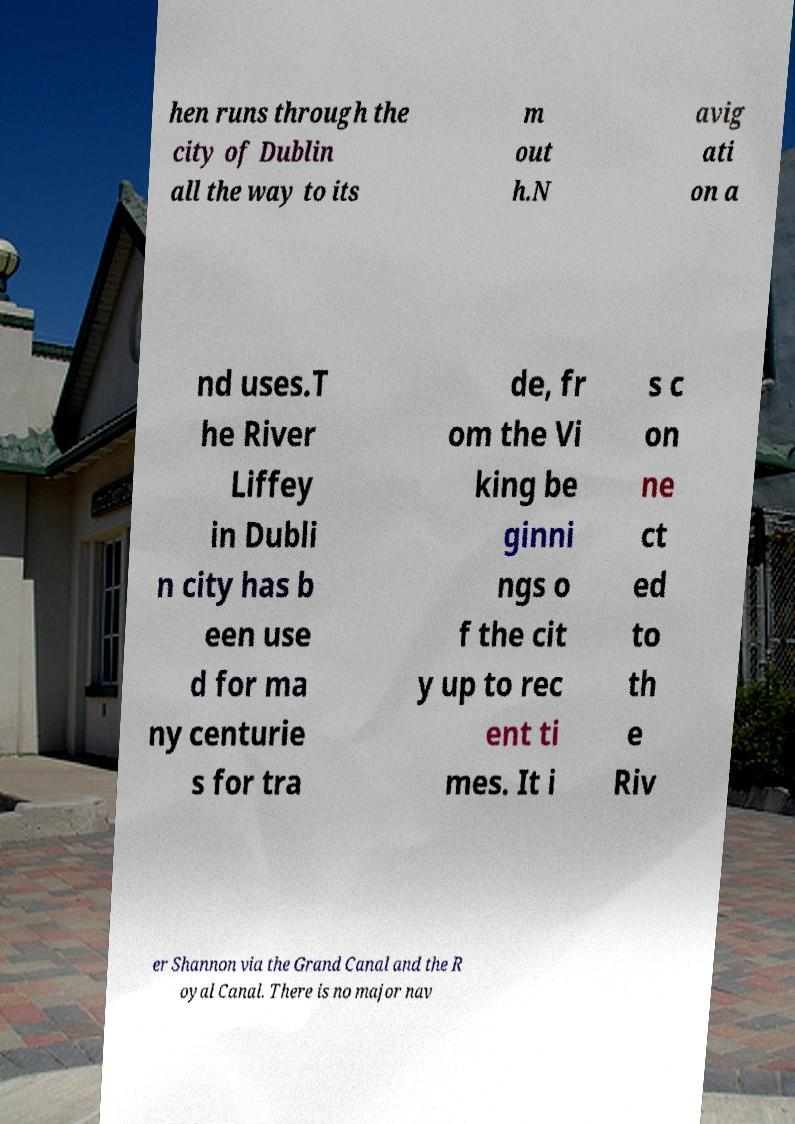I need the written content from this picture converted into text. Can you do that? hen runs through the city of Dublin all the way to its m out h.N avig ati on a nd uses.T he River Liffey in Dubli n city has b een use d for ma ny centurie s for tra de, fr om the Vi king be ginni ngs o f the cit y up to rec ent ti mes. It i s c on ne ct ed to th e Riv er Shannon via the Grand Canal and the R oyal Canal. There is no major nav 